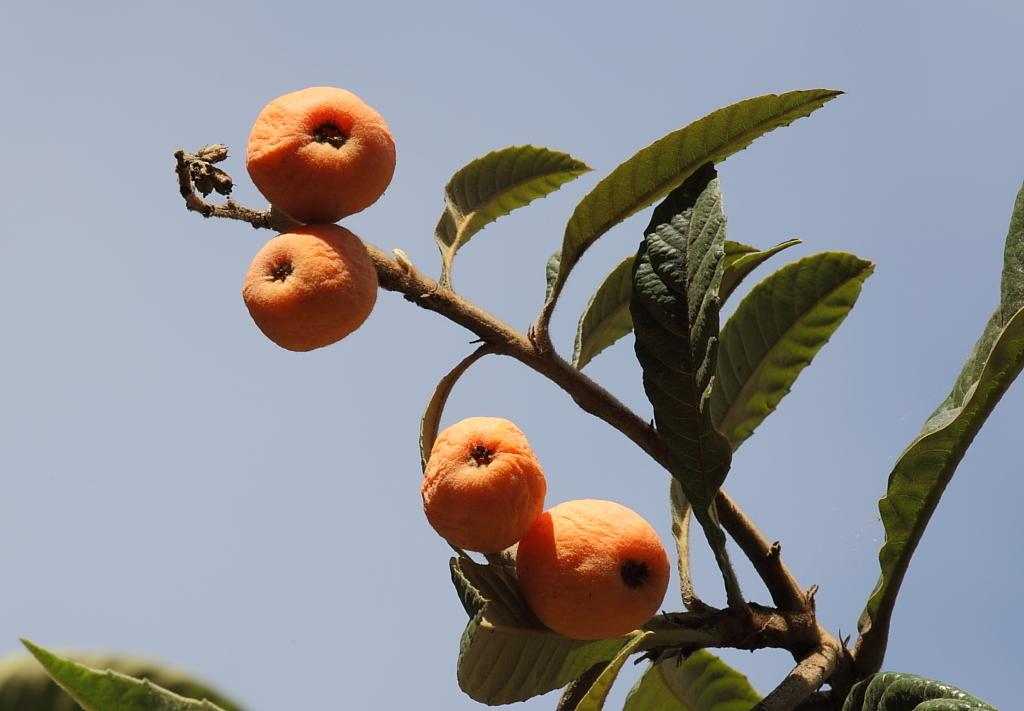What is present in the tree in the picture? There are fruits in the tree in the picture. What can be seen in the background of the picture? The sky is visible in the background of the picture. What is the temper of the fruit in the picture? The temper of the fruit cannot be determined from the image, as fruits do not have emotions or temperament. 